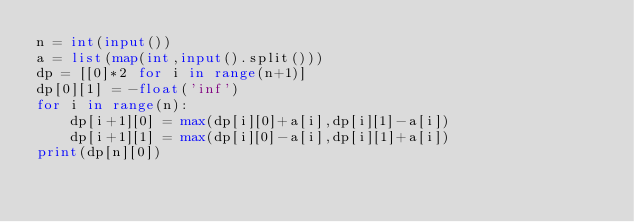Convert code to text. <code><loc_0><loc_0><loc_500><loc_500><_Python_>n = int(input())
a = list(map(int,input().split()))
dp = [[0]*2 for i in range(n+1)]
dp[0][1] = -float('inf')
for i in range(n):
    dp[i+1][0] = max(dp[i][0]+a[i],dp[i][1]-a[i])
    dp[i+1][1] = max(dp[i][0]-a[i],dp[i][1]+a[i])
print(dp[n][0])</code> 